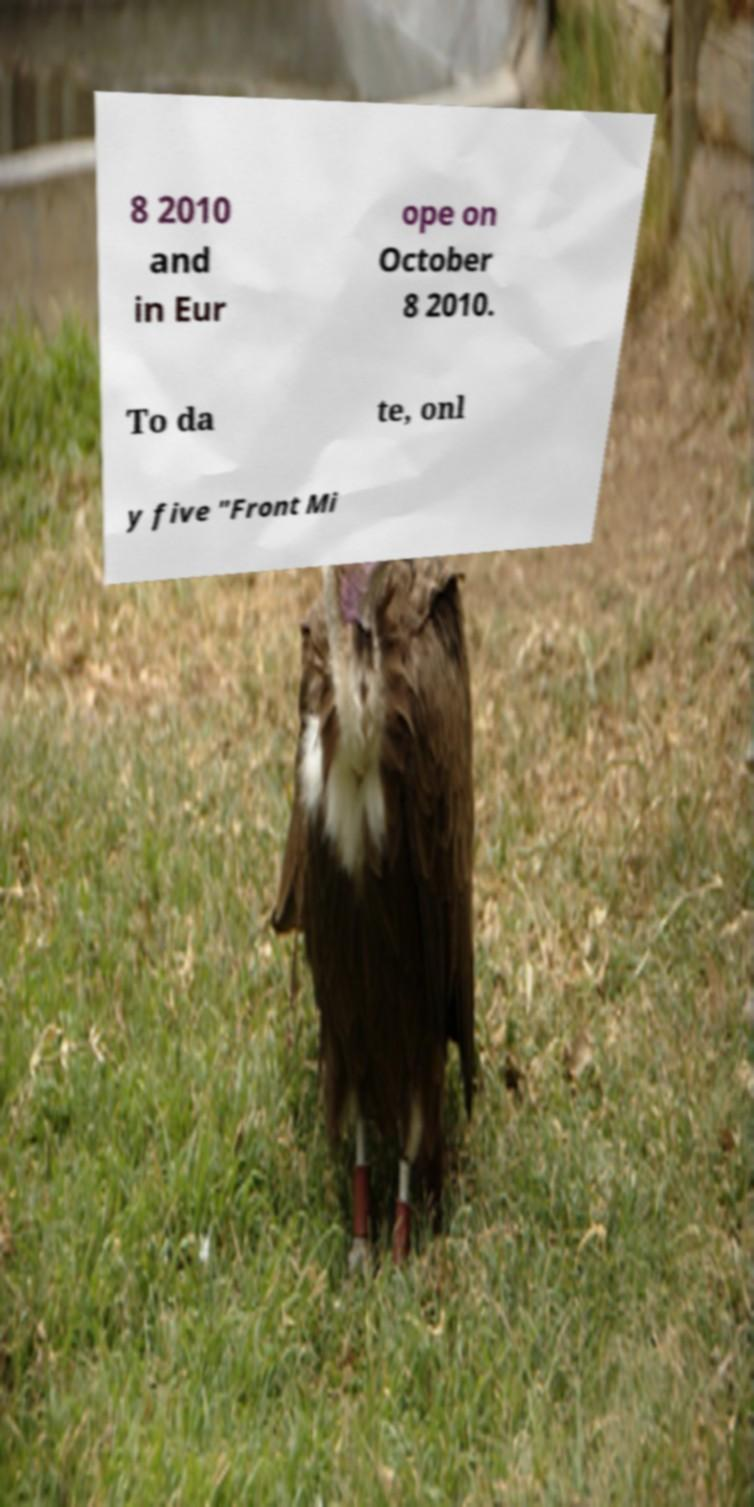Can you accurately transcribe the text from the provided image for me? 8 2010 and in Eur ope on October 8 2010. To da te, onl y five "Front Mi 